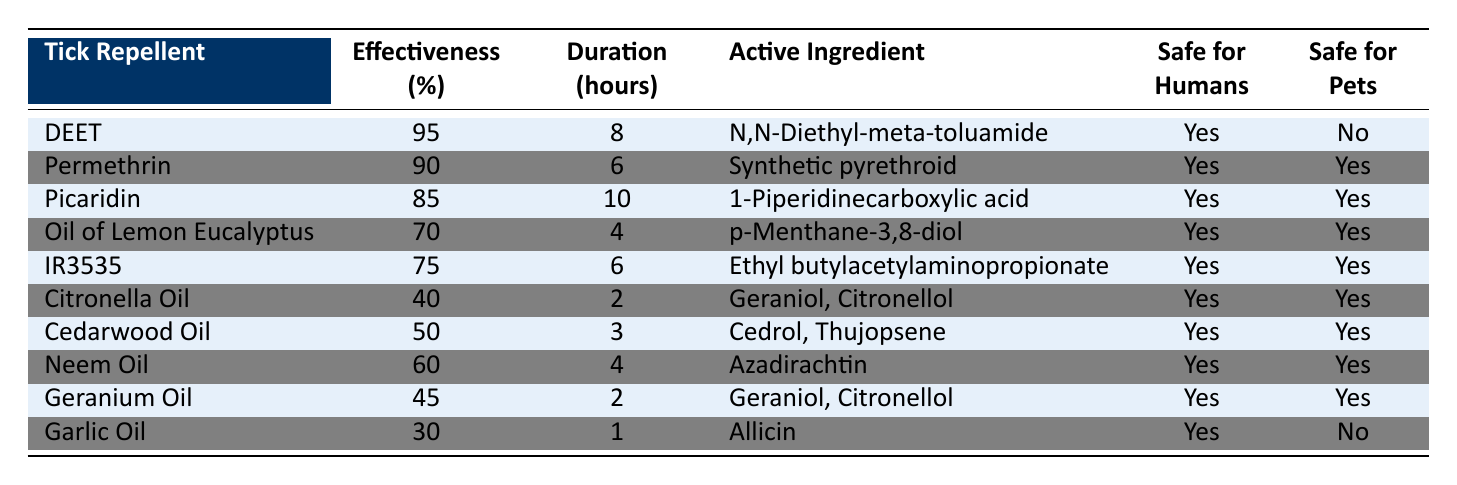What is the most effective tick repellent listed in the table? The table shows "DEET" with an effectiveness of 95%, which is the highest among all listed repellents. Therefore, the most effective tick repellent is DEET.
Answer: DEET Which tick repellent is safe for pets and has an effectiveness above 70%? From the table, "Permethrin," "Picaridin," "Oil of Lemon Eucalyptus," and "IR3535" are the repellents that are both safe for pets and have effectiveness above 70%. The effectiveness values are 90%, 85%, 70%, and 75%, respectively.
Answer: Permethrin, Picaridin, Oil of Lemon Eucalyptus, IR3535 What is the active ingredient in IR3535? The table indicates that the active ingredient in IR3535 is "Ethyl butylacetylaminopropionate."
Answer: Ethyl butylacetylaminopropionate Is Garlic Oil safe for humans? Looking at the table, it states "Yes" in the column for safe for humans.
Answer: Yes Which tick repellent has the longest duration of effectiveness? The table reveals that "Picaridin" has the longest duration of effectiveness at 10 hours, which is greater than any other repellents listed.
Answer: Picaridin What is the average effectiveness of tick repellents that are safe for pets? The effective repellents that are safe for pets are "Permethrin" (90%), "Picaridin" (85%), "Oil of Lemon Eucalyptus" (70%), "IR3535" (75%), "Citronella Oil" (40%), "Cedarwood Oil" (50%), "Neem Oil" (60%), and "Geranium Oil" (45%). Summing their effectiveness gives 90 + 85 + 70 + 75 + 40 + 50 + 60 + 45 = 515. Dividing that by the 8 repellents gives an average of 515/8 = 64.375.
Answer: 64.375 How many tick repellents listed are not safe for pets? Referring to the table, the tick repellents that are not safe for pets are "DEET" and "Garlic Oil." Therefore, there are 2 repellents in total that are not safe for pets.
Answer: 2 Which repellent has an effectiveness of exactly 30%? The table shows that no repellent has an effectiveness of exactly 30%. The closest values to 30% are "Garlic Oil" at 30%. However, it is not exactly 30% for any other repellent.
Answer: None How does the effectiveness of Neem Oil compare to that of Citronella Oil? According to the table, Neem Oil has an effectiveness of 60% while Citronella Oil has an effectiveness of 40%. This means Neem Oil is more effective, surpassing Citronella Oil by 20%.
Answer: Neem Oil is more effective than Citronella Oil 